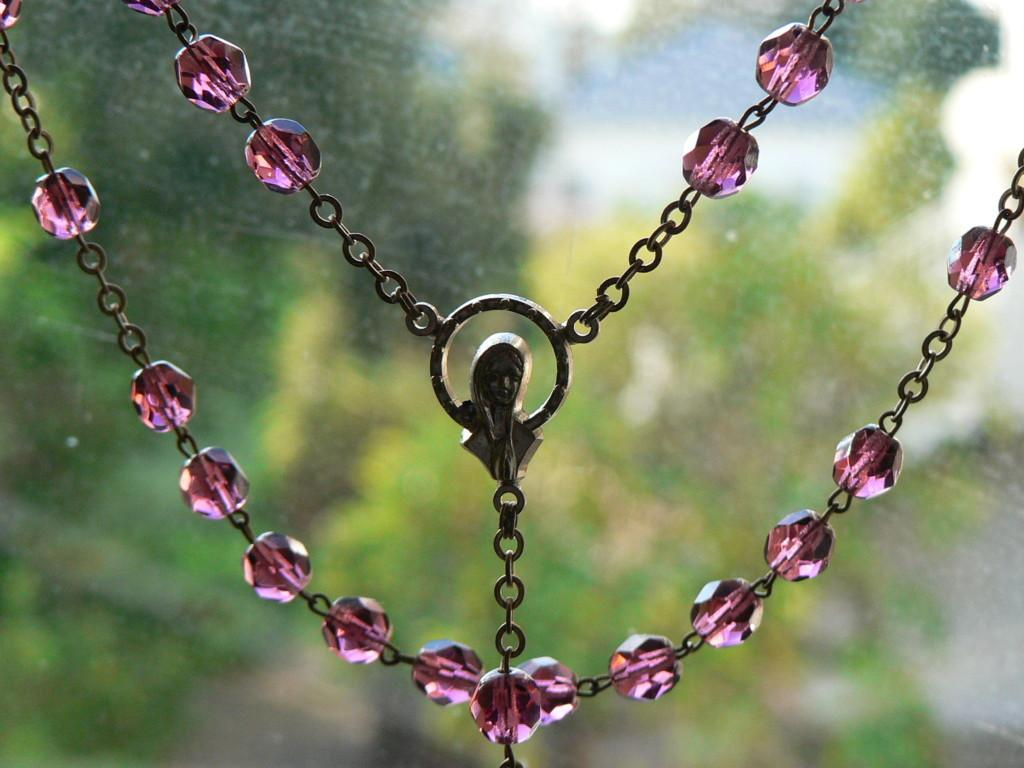What is the main object in the image? There is a chain in the image. What is attached to the chain? There is a locket in the middle of the chain. What shape is the locket? The locket is shaped like a human. How many competitors are participating in the competition shown in the image? There is no competition present in the image; it features a chain with a locket shaped like a human. What type of rock can be seen in the image? There is no rock present in the image; it features a chain with a locket shaped like a human. 